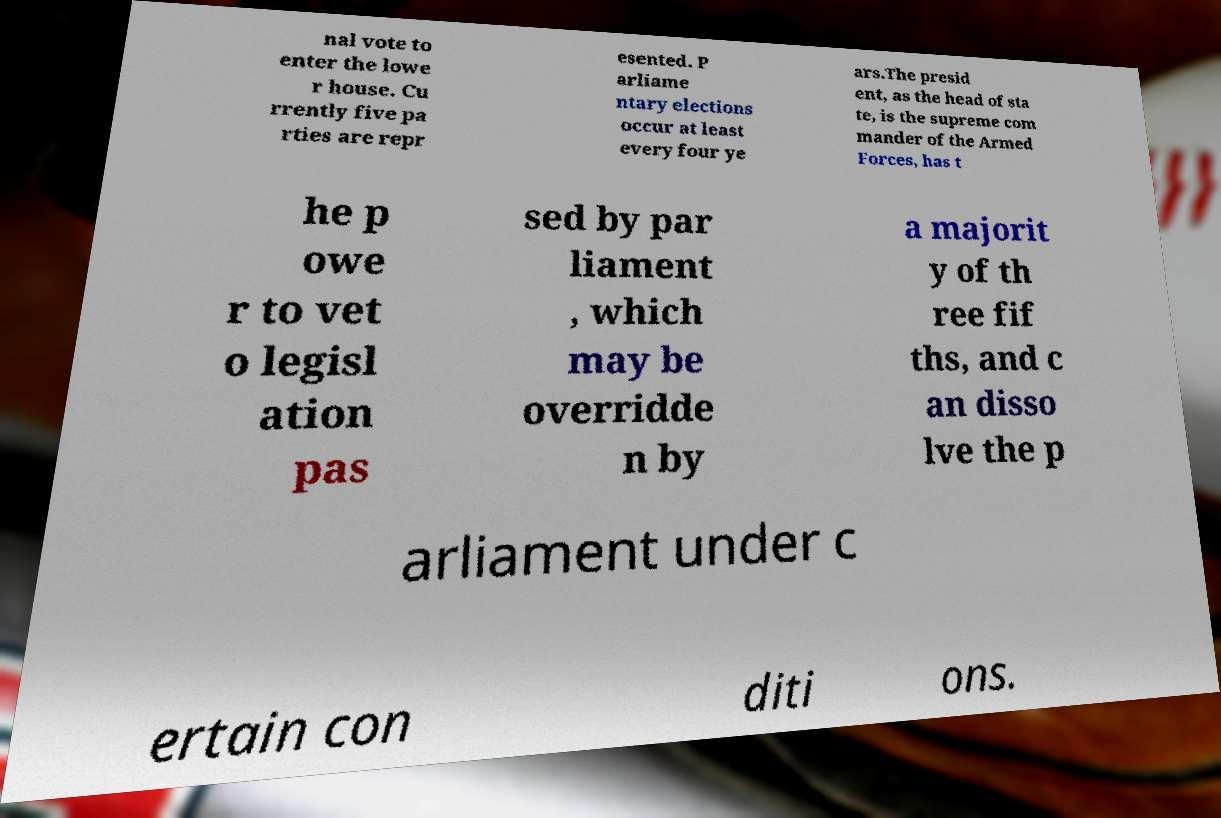I need the written content from this picture converted into text. Can you do that? nal vote to enter the lowe r house. Cu rrently five pa rties are repr esented. P arliame ntary elections occur at least every four ye ars.The presid ent, as the head of sta te, is the supreme com mander of the Armed Forces, has t he p owe r to vet o legisl ation pas sed by par liament , which may be overridde n by a majorit y of th ree fif ths, and c an disso lve the p arliament under c ertain con diti ons. 